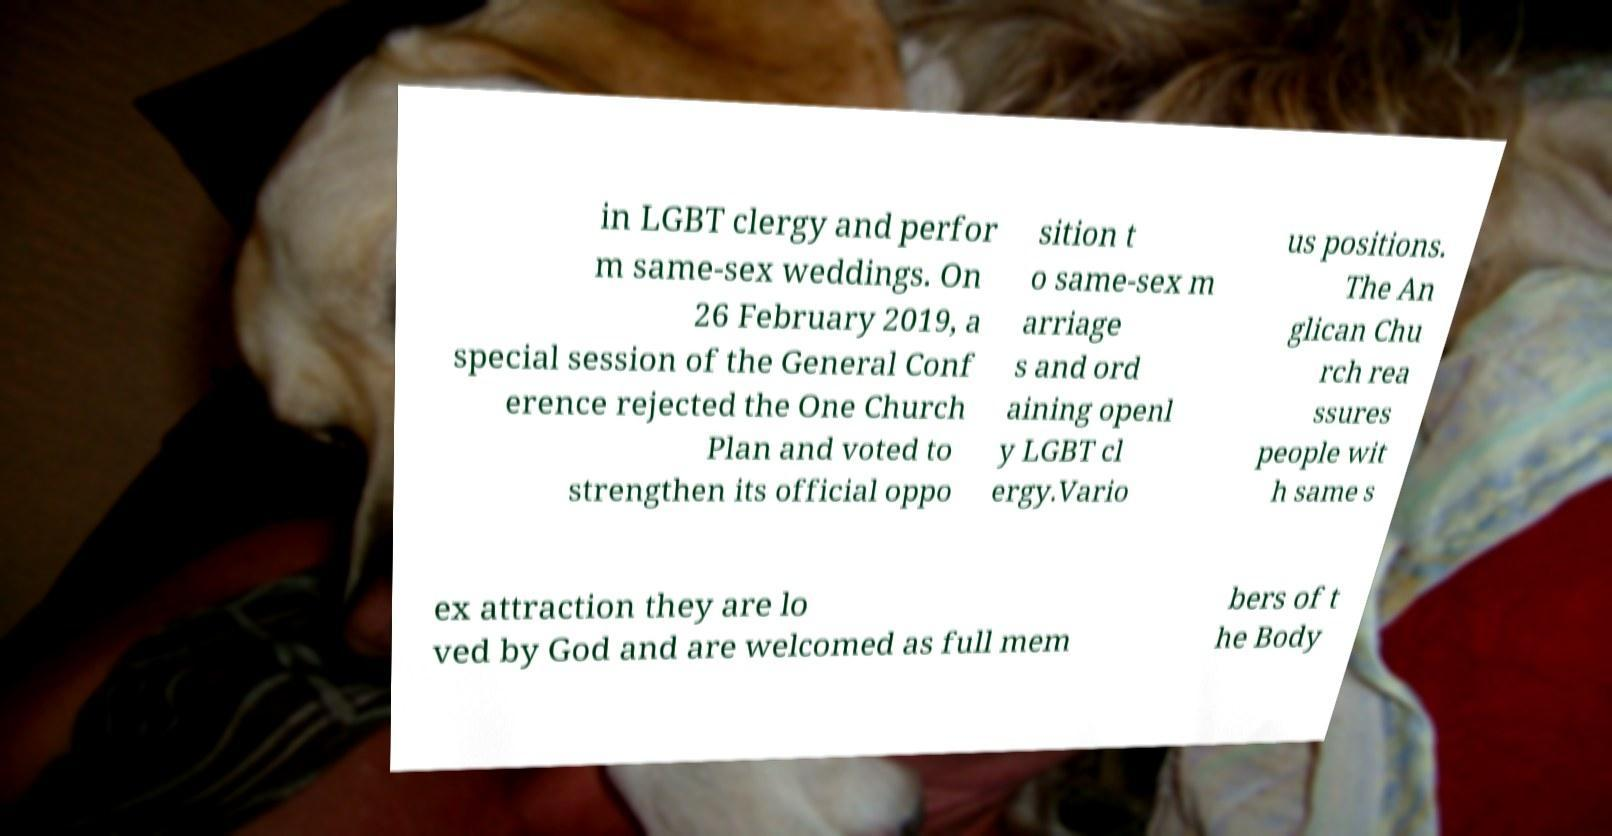What messages or text are displayed in this image? I need them in a readable, typed format. in LGBT clergy and perfor m same-sex weddings. On 26 February 2019, a special session of the General Conf erence rejected the One Church Plan and voted to strengthen its official oppo sition t o same-sex m arriage s and ord aining openl y LGBT cl ergy.Vario us positions. The An glican Chu rch rea ssures people wit h same s ex attraction they are lo ved by God and are welcomed as full mem bers of t he Body 